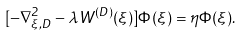Convert formula to latex. <formula><loc_0><loc_0><loc_500><loc_500>[ - \nabla _ { \xi , D } ^ { 2 } - \lambda W ^ { ( D ) } ( \xi ) ] \Phi ( \xi ) = \eta \Phi ( \xi ) .</formula> 